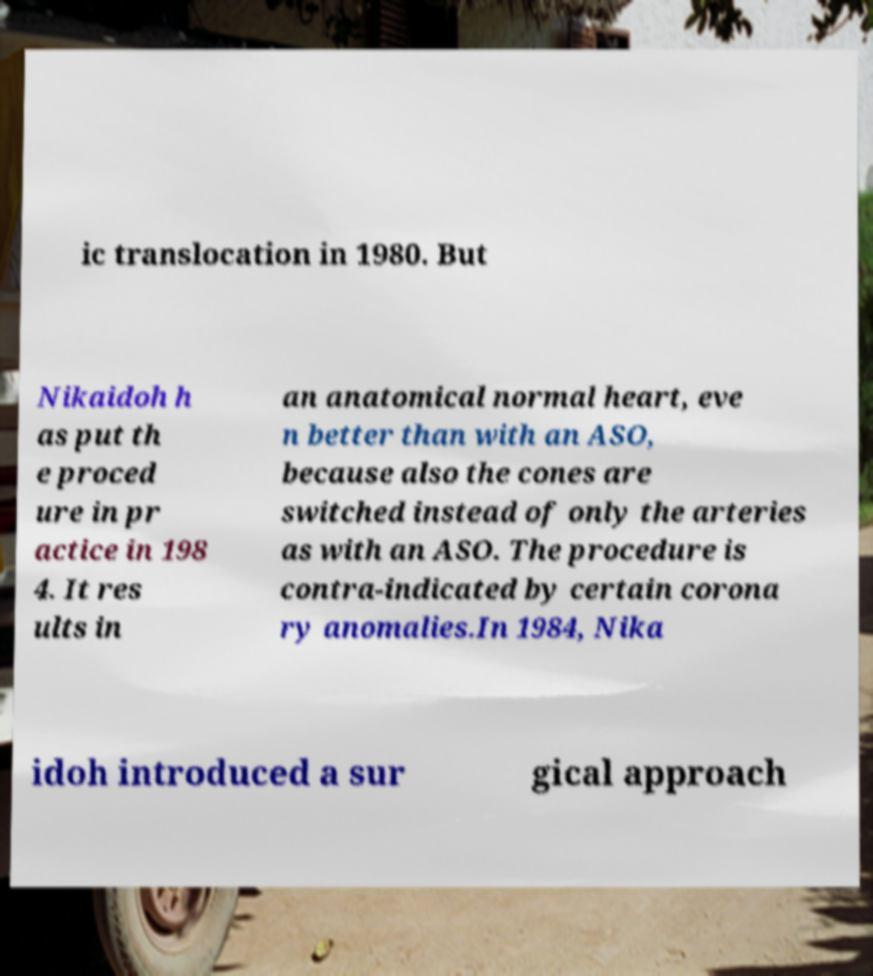Could you extract and type out the text from this image? ic translocation in 1980. But Nikaidoh h as put th e proced ure in pr actice in 198 4. It res ults in an anatomical normal heart, eve n better than with an ASO, because also the cones are switched instead of only the arteries as with an ASO. The procedure is contra-indicated by certain corona ry anomalies.In 1984, Nika idoh introduced a sur gical approach 